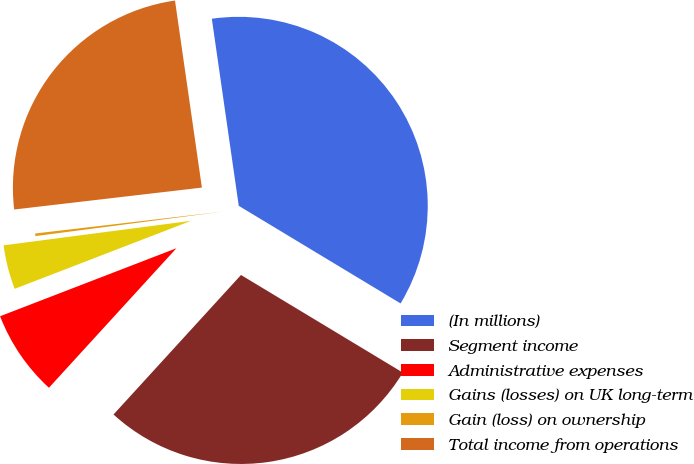Convert chart to OTSL. <chart><loc_0><loc_0><loc_500><loc_500><pie_chart><fcel>(In millions)<fcel>Segment income<fcel>Administrative expenses<fcel>Gains (losses) on UK long-term<fcel>Gain (loss) on ownership<fcel>Total income from operations<nl><fcel>35.92%<fcel>28.15%<fcel>7.36%<fcel>3.79%<fcel>0.22%<fcel>24.58%<nl></chart> 